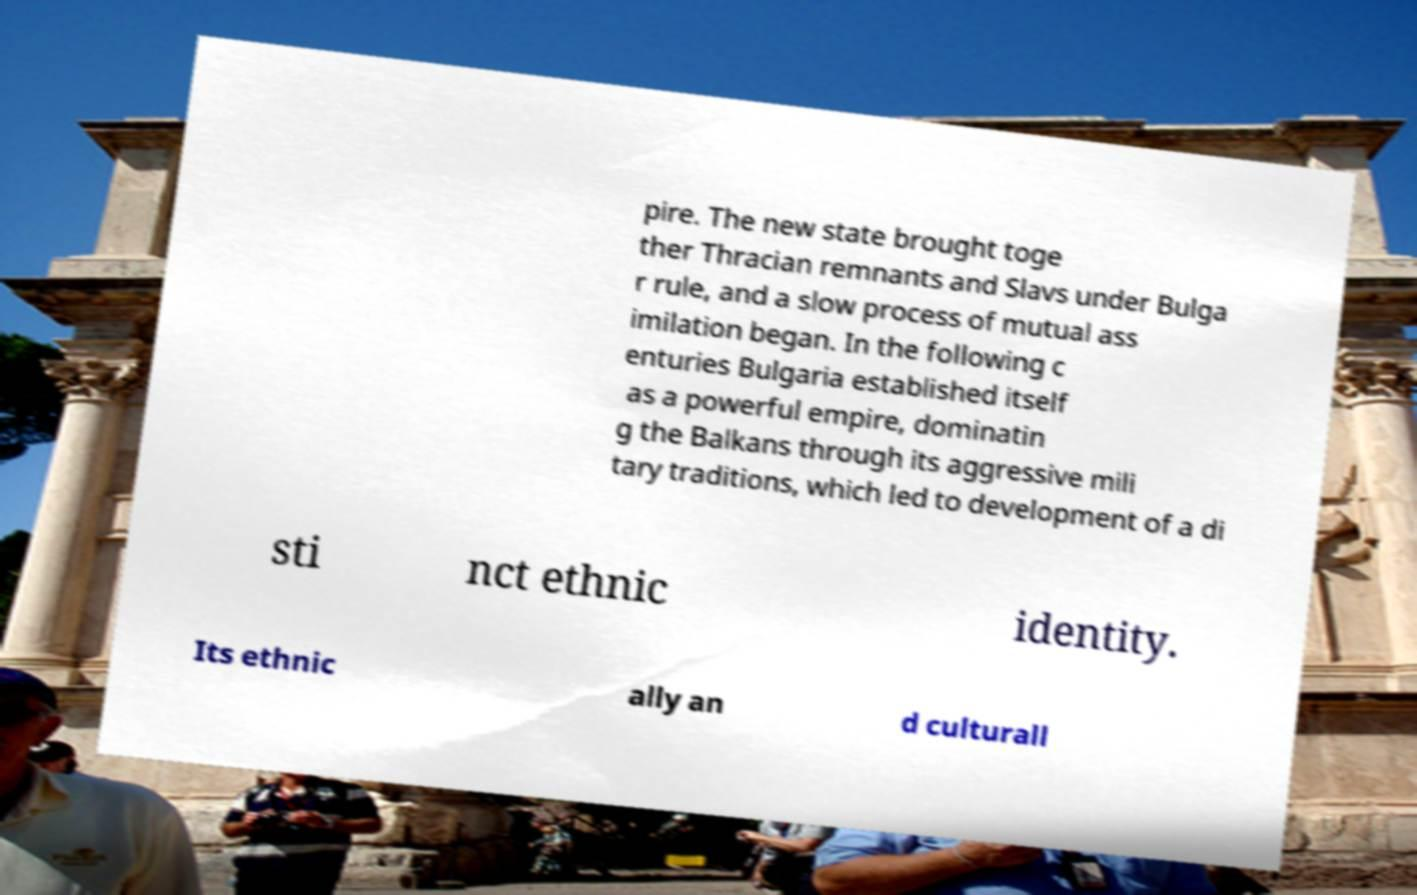Please read and relay the text visible in this image. What does it say? pire. The new state brought toge ther Thracian remnants and Slavs under Bulga r rule, and a slow process of mutual ass imilation began. In the following c enturies Bulgaria established itself as a powerful empire, dominatin g the Balkans through its aggressive mili tary traditions, which led to development of a di sti nct ethnic identity. Its ethnic ally an d culturall 